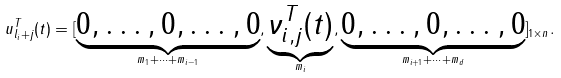Convert formula to latex. <formula><loc_0><loc_0><loc_500><loc_500>u _ { l _ { i } + j } ^ { T } ( t ) = [ \underbrace { 0 , \dots , 0 , \dots , 0 } _ { m _ { 1 } + \dots + m _ { i - 1 } } , \underbrace { \nu _ { i , j } ^ { T } ( t ) } _ { m _ { i } } , \underbrace { 0 , \dots , 0 , \dots , 0 } _ { m _ { i + 1 } + \dots + m _ { d } } ] _ { 1 \times n } .</formula> 